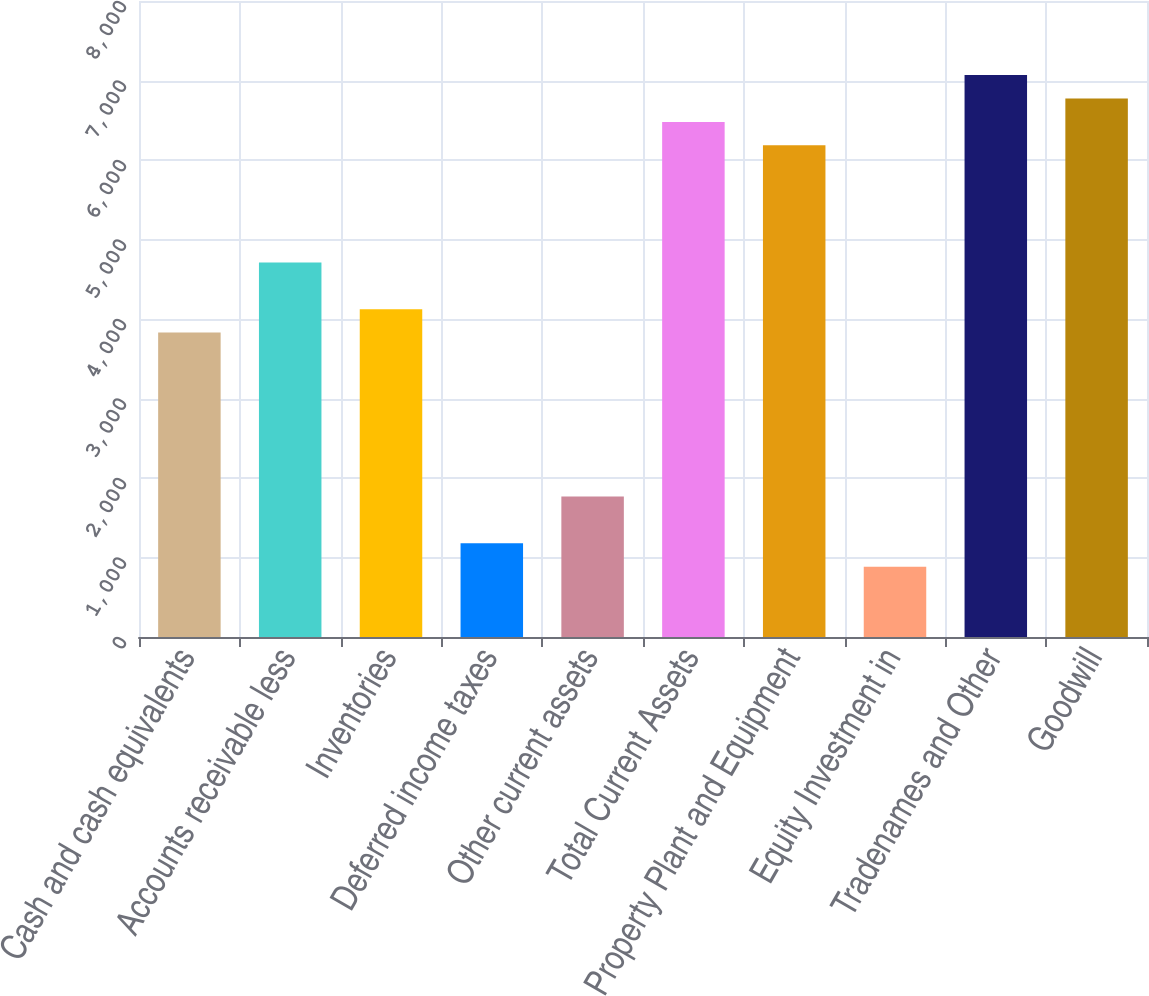Convert chart. <chart><loc_0><loc_0><loc_500><loc_500><bar_chart><fcel>Cash and cash equivalents<fcel>Accounts receivable less<fcel>Inventories<fcel>Deferred income taxes<fcel>Other current assets<fcel>Total Current Assets<fcel>Property Plant and Equipment<fcel>Equity Investment in<fcel>Tradenames and Other<fcel>Goodwill<nl><fcel>3828.7<fcel>4712.2<fcel>4123.2<fcel>1178.2<fcel>1767.2<fcel>6479.2<fcel>6184.7<fcel>883.7<fcel>7068.2<fcel>6773.7<nl></chart> 